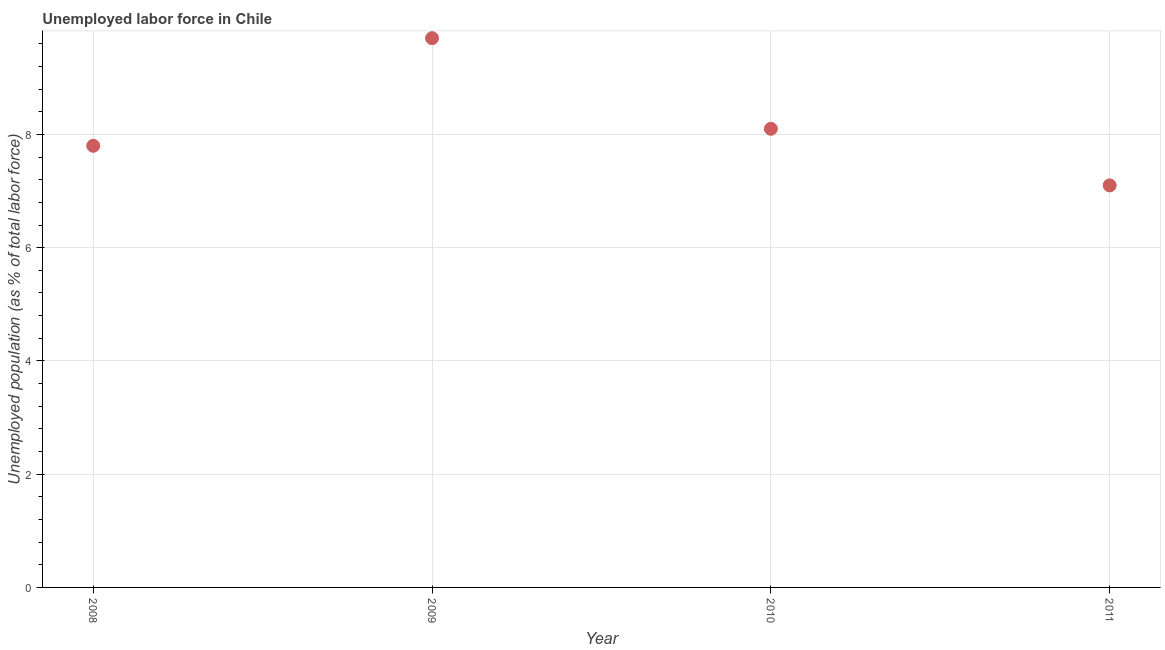What is the total unemployed population in 2010?
Provide a short and direct response. 8.1. Across all years, what is the maximum total unemployed population?
Keep it short and to the point. 9.7. Across all years, what is the minimum total unemployed population?
Your answer should be very brief. 7.1. What is the sum of the total unemployed population?
Give a very brief answer. 32.7. What is the difference between the total unemployed population in 2008 and 2010?
Offer a very short reply. -0.3. What is the average total unemployed population per year?
Ensure brevity in your answer.  8.18. What is the median total unemployed population?
Your answer should be very brief. 7.95. In how many years, is the total unemployed population greater than 1.2000000000000002 %?
Offer a terse response. 4. What is the ratio of the total unemployed population in 2009 to that in 2011?
Your answer should be very brief. 1.37. What is the difference between the highest and the second highest total unemployed population?
Offer a terse response. 1.6. What is the difference between the highest and the lowest total unemployed population?
Provide a short and direct response. 2.6. In how many years, is the total unemployed population greater than the average total unemployed population taken over all years?
Your response must be concise. 1. How many years are there in the graph?
Your response must be concise. 4. Are the values on the major ticks of Y-axis written in scientific E-notation?
Provide a short and direct response. No. Does the graph contain any zero values?
Make the answer very short. No. What is the title of the graph?
Provide a succinct answer. Unemployed labor force in Chile. What is the label or title of the Y-axis?
Your answer should be very brief. Unemployed population (as % of total labor force). What is the Unemployed population (as % of total labor force) in 2008?
Offer a terse response. 7.8. What is the Unemployed population (as % of total labor force) in 2009?
Your response must be concise. 9.7. What is the Unemployed population (as % of total labor force) in 2010?
Give a very brief answer. 8.1. What is the Unemployed population (as % of total labor force) in 2011?
Provide a short and direct response. 7.1. What is the difference between the Unemployed population (as % of total labor force) in 2008 and 2009?
Keep it short and to the point. -1.9. What is the difference between the Unemployed population (as % of total labor force) in 2008 and 2011?
Give a very brief answer. 0.7. What is the difference between the Unemployed population (as % of total labor force) in 2009 and 2010?
Offer a very short reply. 1.6. What is the ratio of the Unemployed population (as % of total labor force) in 2008 to that in 2009?
Offer a terse response. 0.8. What is the ratio of the Unemployed population (as % of total labor force) in 2008 to that in 2011?
Make the answer very short. 1.1. What is the ratio of the Unemployed population (as % of total labor force) in 2009 to that in 2010?
Offer a terse response. 1.2. What is the ratio of the Unemployed population (as % of total labor force) in 2009 to that in 2011?
Give a very brief answer. 1.37. What is the ratio of the Unemployed population (as % of total labor force) in 2010 to that in 2011?
Ensure brevity in your answer.  1.14. 